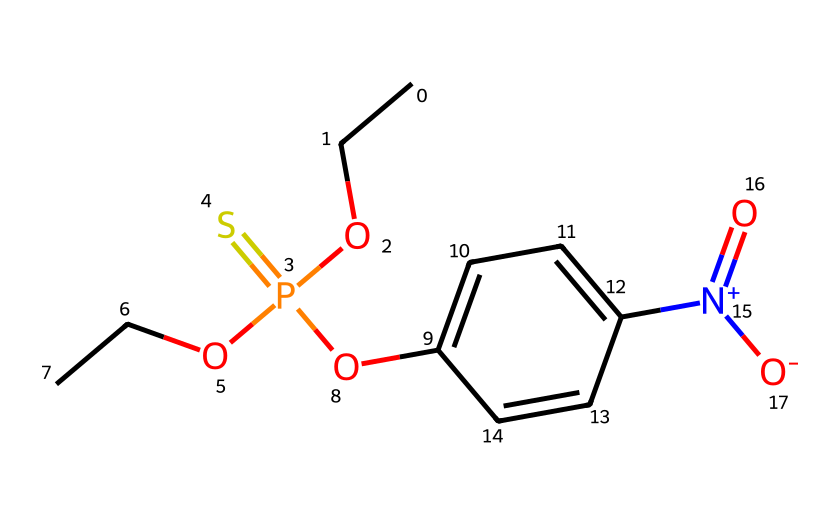How many phosphorus atoms are present in this chemical? The chemical structure includes one phosphorus atom located in the central part of the molecule, as indicated by the "P" in the SMILES representation.
Answer: 1 What is the functional group of this compound? The structure contains a phosphorus atom bonded to oxygen and sulfur atoms, which characterizes it as an organophosphate. The "P(=S)" indicates a phosphorus bonded to sulfur with a double bond, a key feature of organophosphates.
Answer: organophosphate How many oxygen atoms are there in this compound? Examining the SMILES notation, there are four oxygen atoms: two from the alkoxy groups (OCC), one in the phosphate group, and one in the nitro group attached to the aromatic ring.
Answer: 4 What type of nitrogen compound is indicated in this chemical? The presence of the notation "[N+](=O)[O-]" indicates that the nitrogen atom is part of a nitro group, which is a common feature in various pesticides for increased reactivity and function.
Answer: nitro What does the connectivity of this structure suggest about its polarity? The presence of multiple electronegative atoms (N, O, and S) alongside the phosphorus atom indicates that the molecule is polar, as it can create dipole moments due to uneven distribution of electron density.
Answer: polar How many alkoxy groups are present in this compound? The "OCC" parts of the SMILES indicate the presence of two alkoxy groups (as seen in the side chains), confirming the molecule includes two ethers.
Answer: 2 